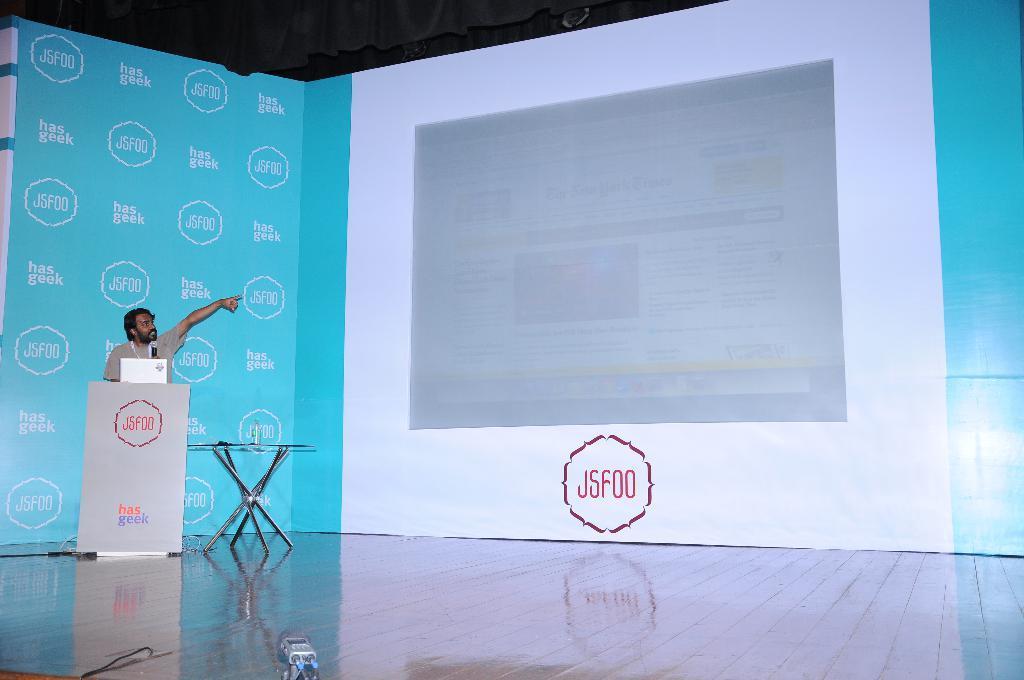Please provide a concise description of this image. In this picture I can see there is a man standing here, behind the wooden frame and there is a microphone and in the backdrop there is a banner and there is a white screen and there is something displayed on the screen. 